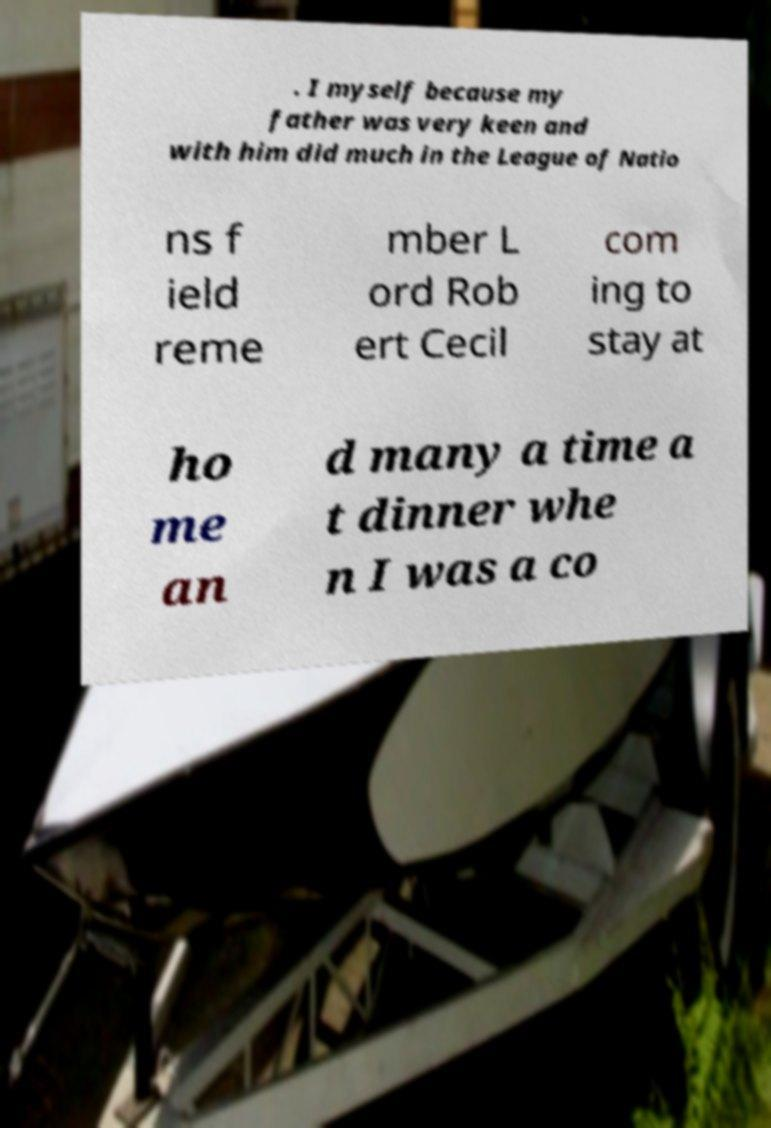For documentation purposes, I need the text within this image transcribed. Could you provide that? . I myself because my father was very keen and with him did much in the League of Natio ns f ield reme mber L ord Rob ert Cecil com ing to stay at ho me an d many a time a t dinner whe n I was a co 